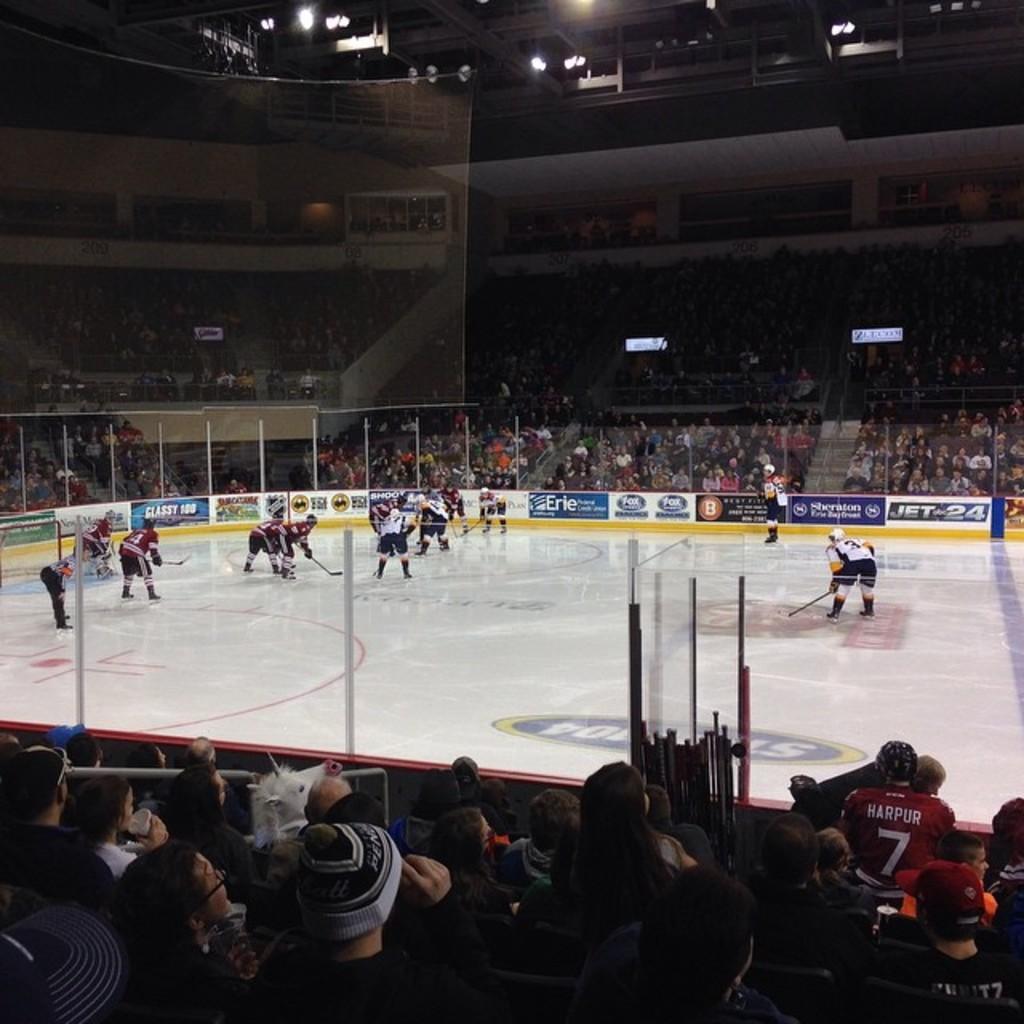Describe this image in one or two sentences. Here in this picture we can see a group of people playing ice hockey on the floor present over there and we can see all of the players are holding hockey bats and wearing gloves and helmets on them and we can see fencing present all around them and we can see people sitting in the stands and watching the game and at the top we can see lights present here and there. 